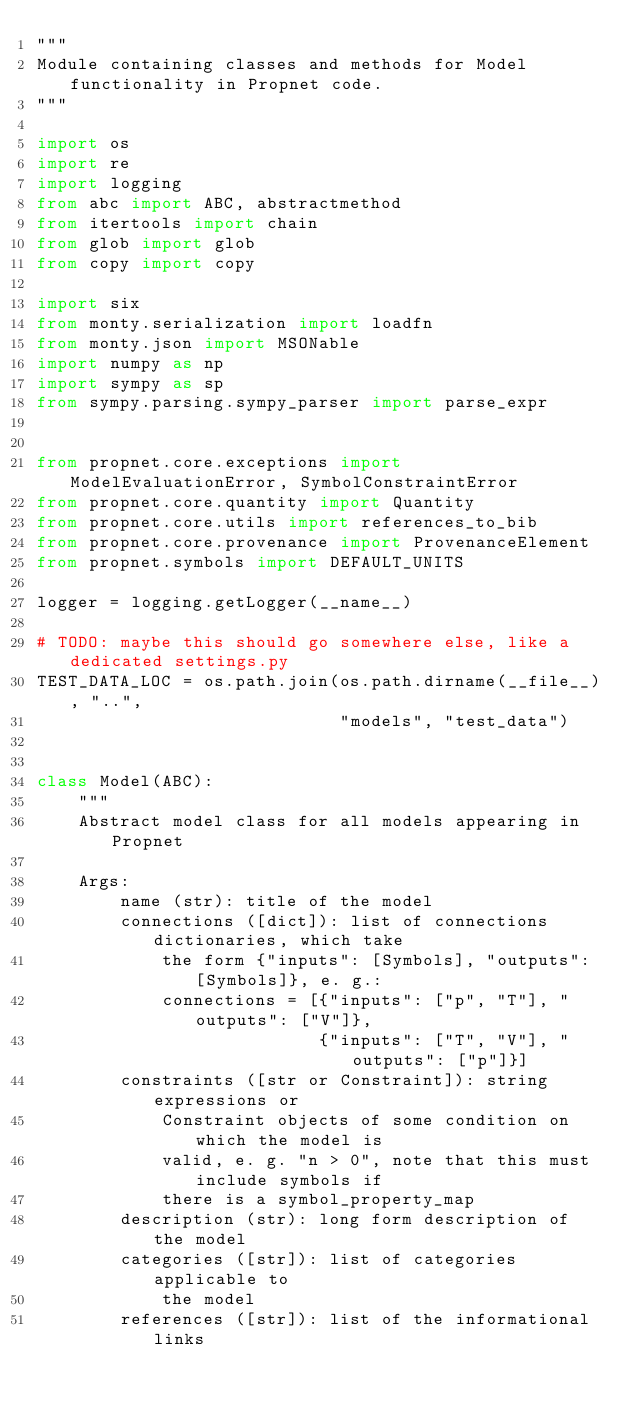<code> <loc_0><loc_0><loc_500><loc_500><_Python_>"""
Module containing classes and methods for Model functionality in Propnet code.
"""

import os
import re
import logging
from abc import ABC, abstractmethod
from itertools import chain
from glob import glob
from copy import copy

import six
from monty.serialization import loadfn
from monty.json import MSONable
import numpy as np
import sympy as sp
from sympy.parsing.sympy_parser import parse_expr


from propnet.core.exceptions import ModelEvaluationError, SymbolConstraintError
from propnet.core.quantity import Quantity
from propnet.core.utils import references_to_bib
from propnet.core.provenance import ProvenanceElement
from propnet.symbols import DEFAULT_UNITS

logger = logging.getLogger(__name__)

# TODO: maybe this should go somewhere else, like a dedicated settings.py
TEST_DATA_LOC = os.path.join(os.path.dirname(__file__), "..",
                             "models", "test_data")


class Model(ABC):
    """
    Abstract model class for all models appearing in Propnet

    Args:
        name (str): title of the model
        connections ([dict]): list of connections dictionaries, which take
            the form {"inputs": [Symbols], "outputs": [Symbols]}, e. g.:
            connections = [{"inputs": ["p", "T"], "outputs": ["V"]},
                           {"inputs": ["T", "V"], "outputs": ["p"]}]
        constraints ([str or Constraint]): string expressions or
            Constraint objects of some condition on which the model is
            valid, e. g. "n > 0", note that this must include symbols if
            there is a symbol_property_map
        description (str): long form description of the model
        categories ([str]): list of categories applicable to
            the model
        references ([str]): list of the informational links</code> 